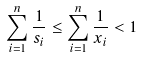Convert formula to latex. <formula><loc_0><loc_0><loc_500><loc_500>\sum _ { i = 1 } ^ { n } \frac { 1 } { s _ { i } } \leq \sum _ { i = 1 } ^ { n } \frac { 1 } { x _ { i } } < 1</formula> 